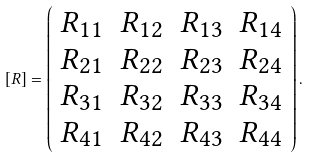<formula> <loc_0><loc_0><loc_500><loc_500>[ R ] = \left ( \begin{array} { c c c c } R _ { 1 1 } & R _ { 1 2 } & R _ { 1 3 } & R _ { 1 4 } \\ R _ { 2 1 } & R _ { 2 2 } & R _ { 2 3 } & R _ { 2 4 } \\ R _ { 3 1 } & R _ { 3 2 } & R _ { 3 3 } & R _ { 3 4 } \\ R _ { 4 1 } & R _ { 4 2 } & R _ { 4 3 } & R _ { 4 4 } \end{array} \right ) .</formula> 